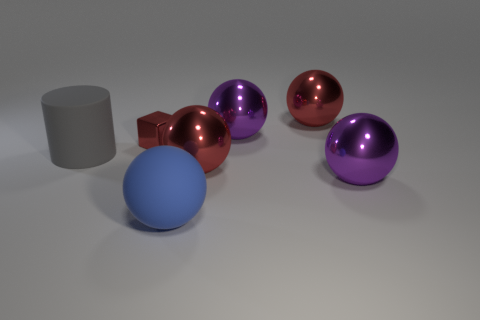Does the tiny metal cube have the same color as the rubber object in front of the large cylinder? no 